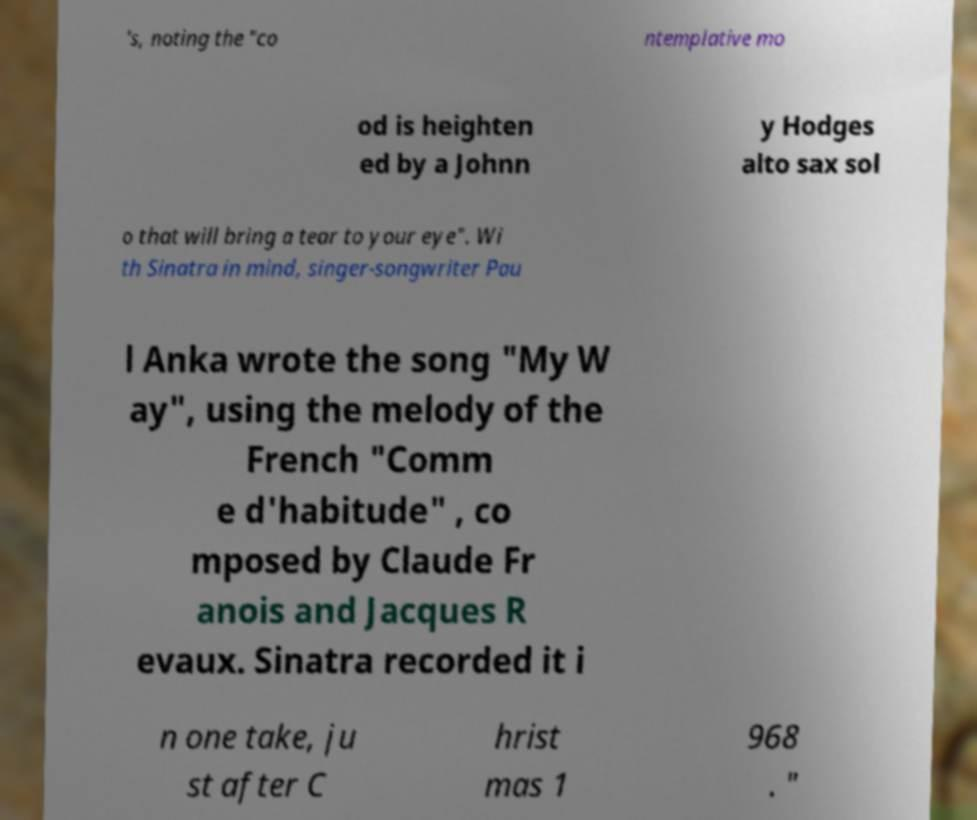For documentation purposes, I need the text within this image transcribed. Could you provide that? 's, noting the "co ntemplative mo od is heighten ed by a Johnn y Hodges alto sax sol o that will bring a tear to your eye". Wi th Sinatra in mind, singer-songwriter Pau l Anka wrote the song "My W ay", using the melody of the French "Comm e d'habitude" , co mposed by Claude Fr anois and Jacques R evaux. Sinatra recorded it i n one take, ju st after C hrist mas 1 968 . " 